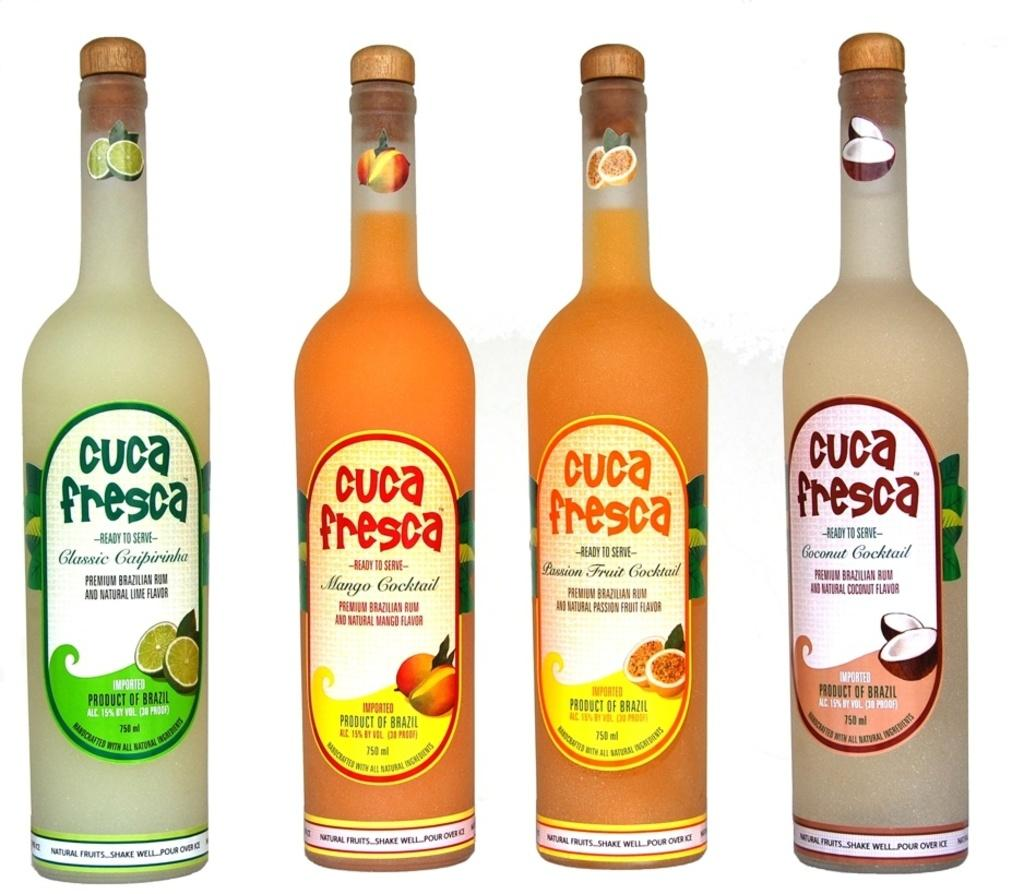<image>
Summarize the visual content of the image. Four bottles of Cuca Fresca all different colors. 